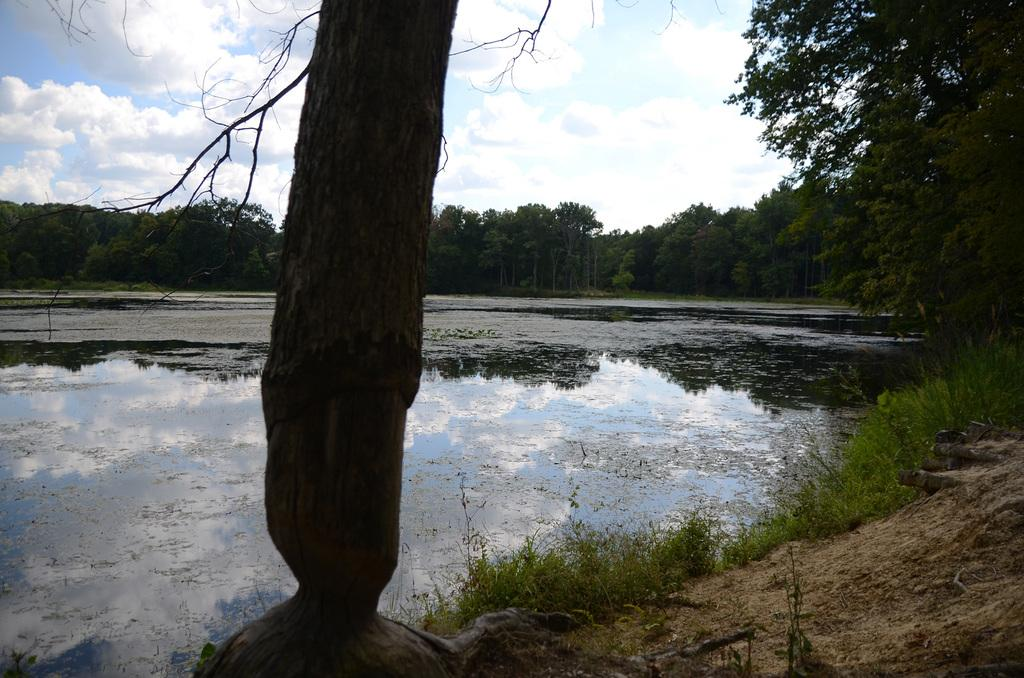What is visible on the ground in the image? The ground is visible in the image. What type of vegetation can be seen in the image? There are plants and trees visible in the image. What is the primary source of water in the image? There is water visible in the image. What is visible at the top of the image? The sky is visible in the image, and clouds are present in the sky. What type of meat can be seen hanging from the trees in the image? There is no meat present in the image; it features plants, trees, and water. What type of home can be seen in the image? There is no home present in the image; it features natural elements such as plants, trees, and water. 